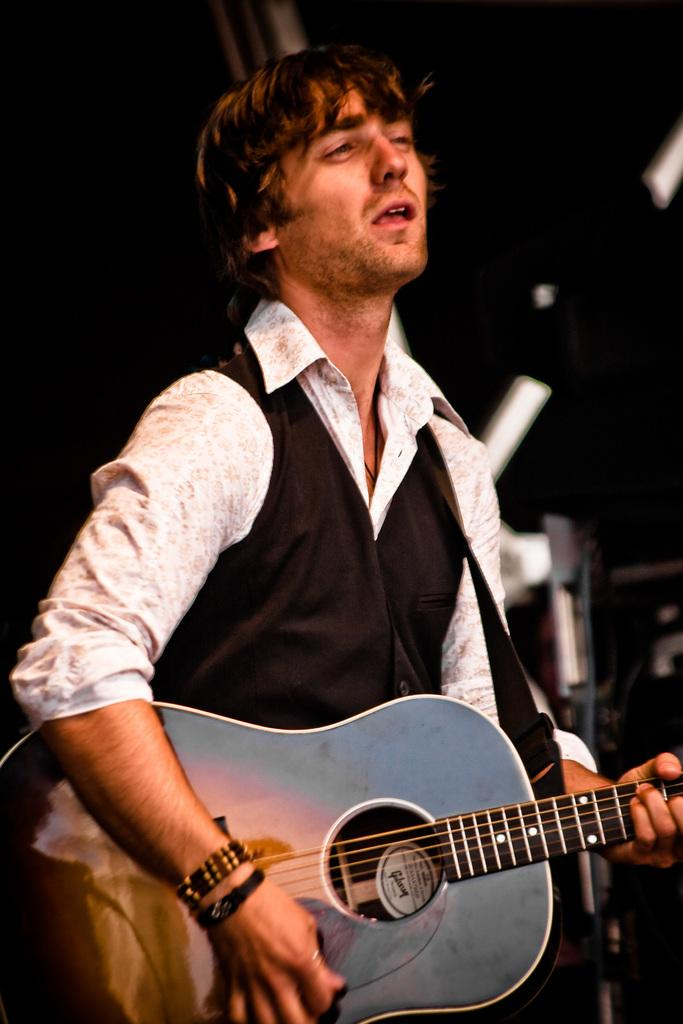What is the main subject of the image? There is a man in the center of the image. What is the man doing in the image? The man is playing a guitar and singing. What type of soap is the man using to sing in the image? There is no soap present in the image, and the man is singing without any apparent use of soap. 